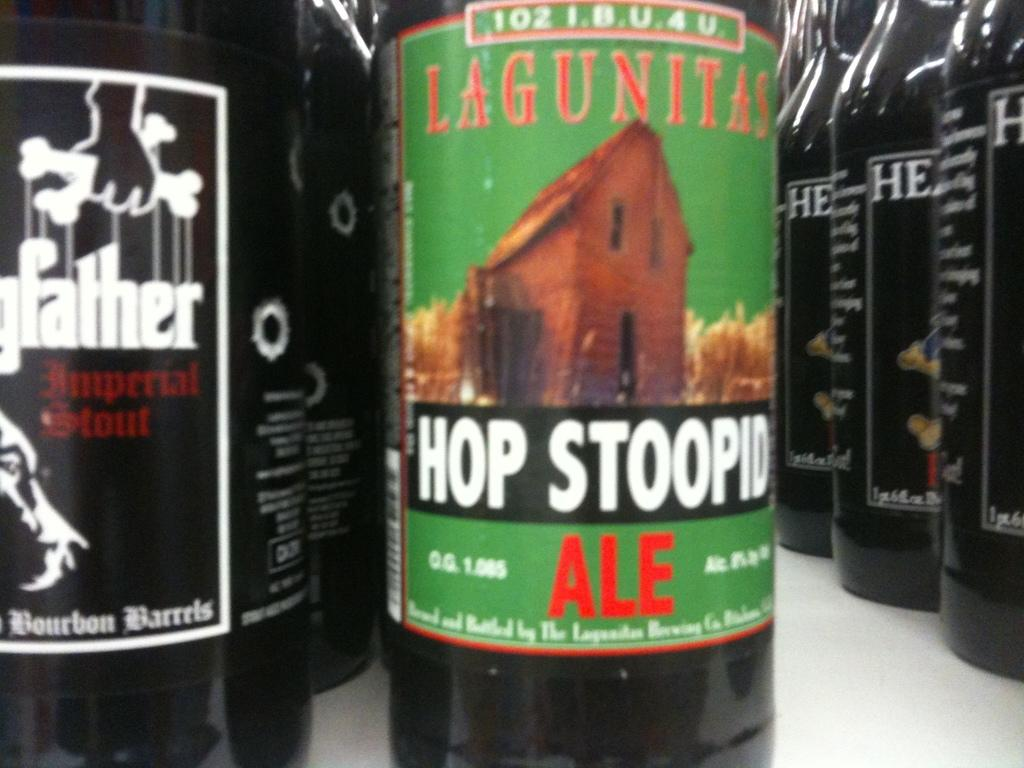Provide a one-sentence caption for the provided image. A row of beer bottles including Lagunitas Hop Stoopid Ale. 